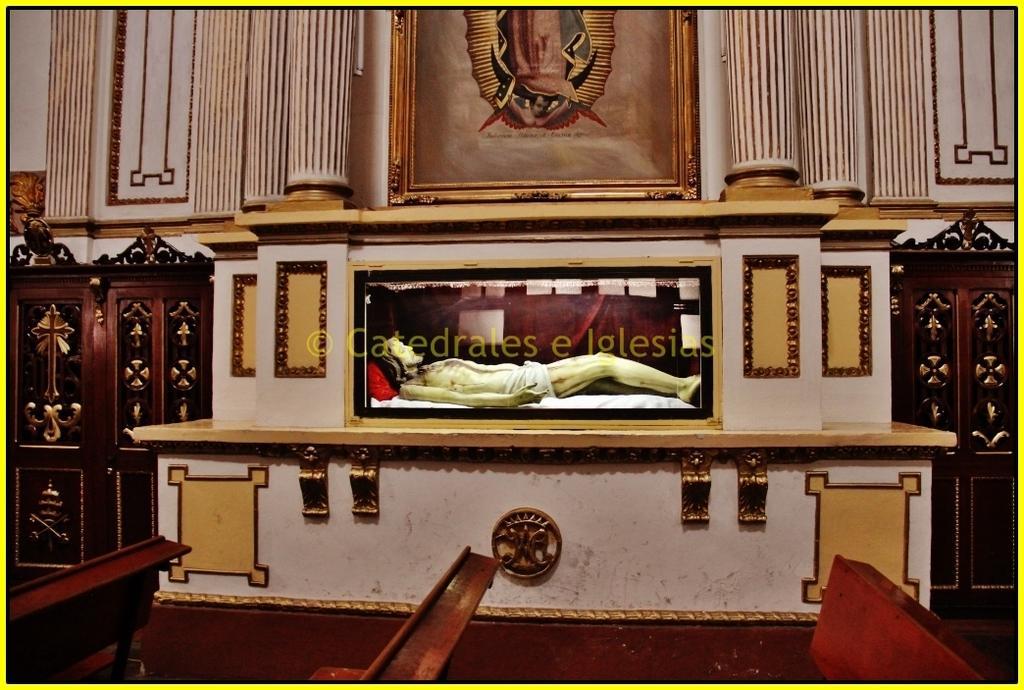In one or two sentences, can you explain what this image depicts? In this image in the center there is one statue and a wall, on the wall there is one photo frame. On the right side and left side there are two cupboards, and at the bottom there are some benches. 